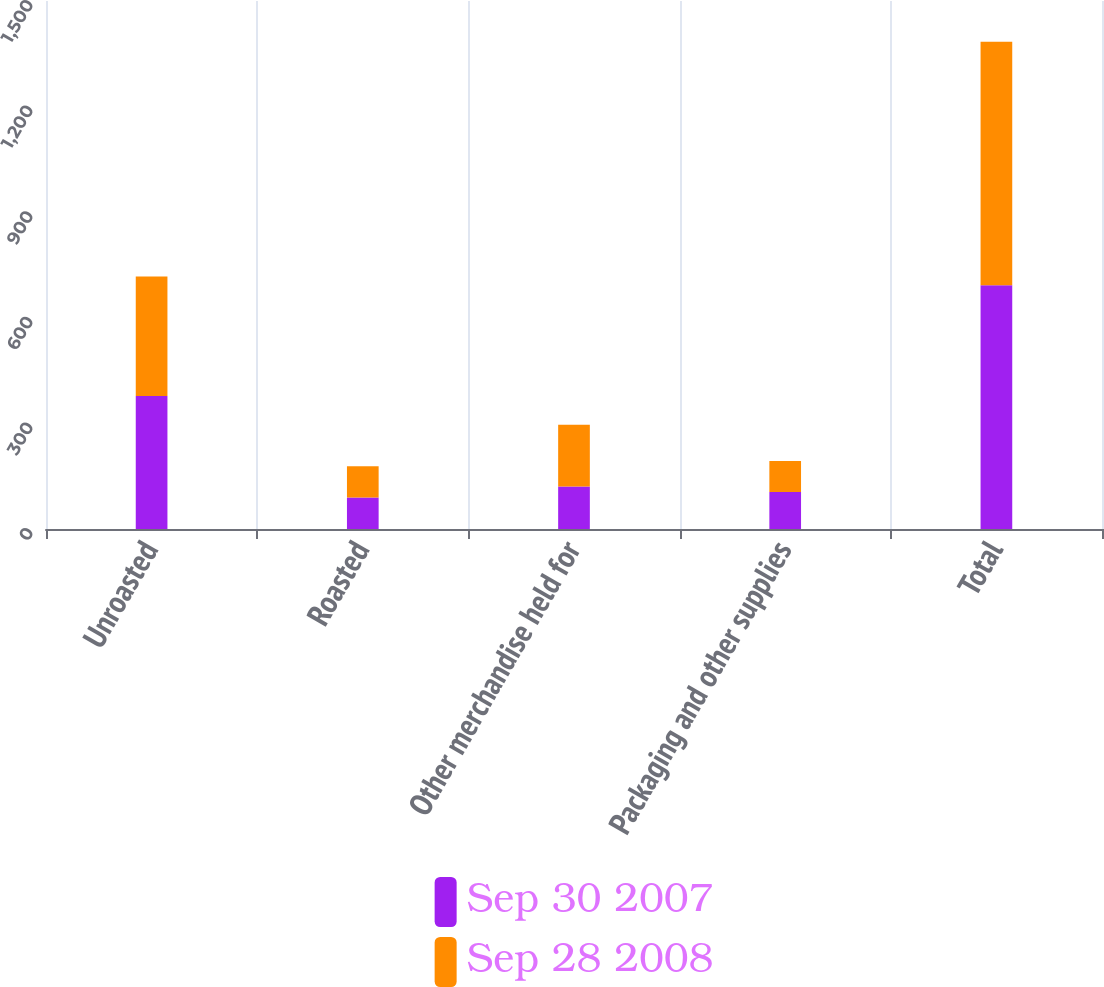Convert chart to OTSL. <chart><loc_0><loc_0><loc_500><loc_500><stacked_bar_chart><ecel><fcel>Unroasted<fcel>Roasted<fcel>Other merchandise held for<fcel>Packaging and other supplies<fcel>Total<nl><fcel>Sep 30 2007<fcel>377.7<fcel>89.6<fcel>120.6<fcel>104.9<fcel>692.8<nl><fcel>Sep 28 2008<fcel>339.5<fcel>88.6<fcel>175.5<fcel>88.1<fcel>691.7<nl></chart> 